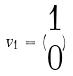<formula> <loc_0><loc_0><loc_500><loc_500>v _ { 1 } = ( \begin{matrix} 1 \\ 0 \end{matrix} )</formula> 